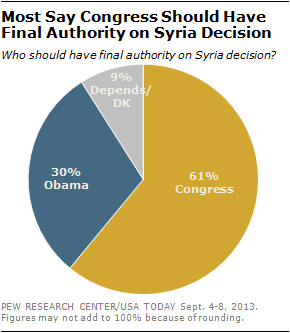Indicate a few pertinent items in this graphic. The value of the largest segment is 61. The result of adding the smallest and second largest segment values is not equal to the value of the largest segment. 